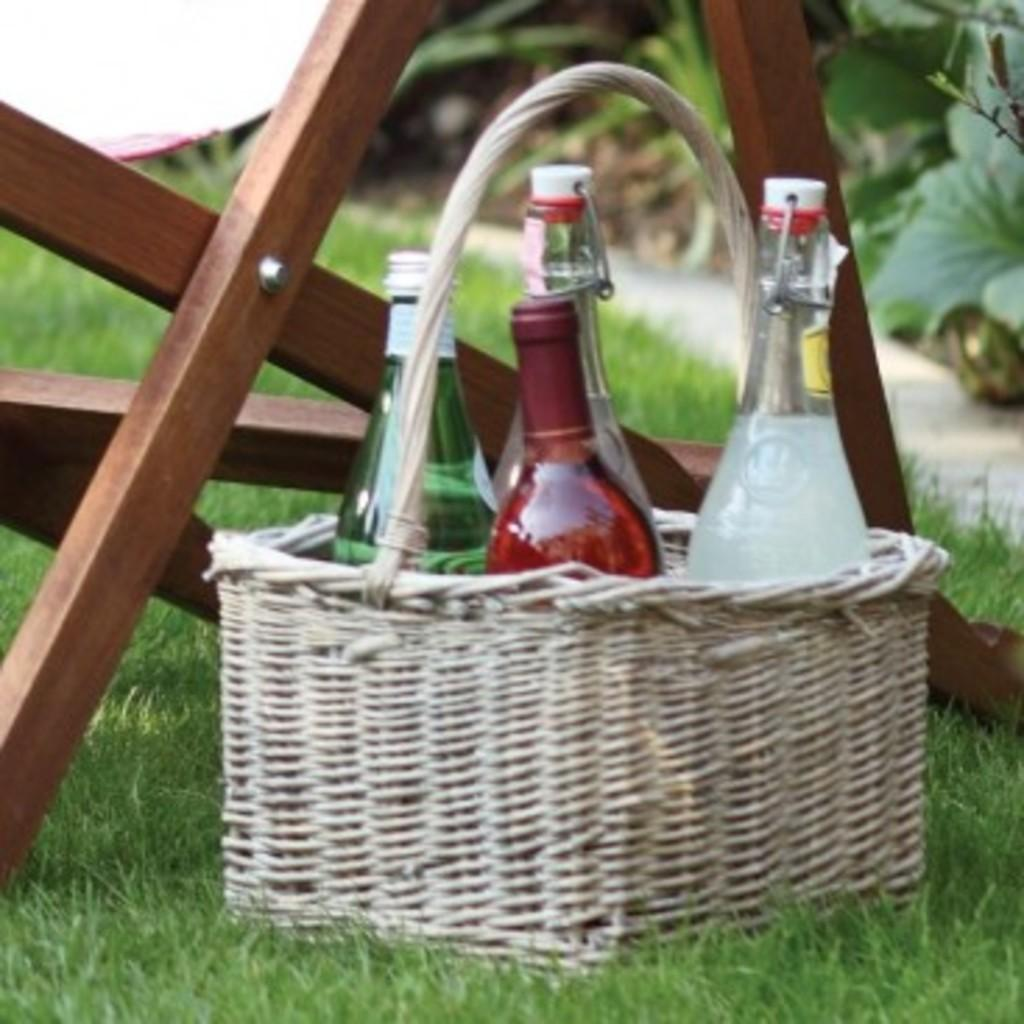What object can be seen in the image that is used for carrying items? There is a basket in the image that is used for carrying items. What type of items are inside the basket? There are wine bottles in the basket. What type of thrill can be experienced by the wine bottles in the image? There is no indication in the image that the wine bottles are experiencing any type of thrill. 